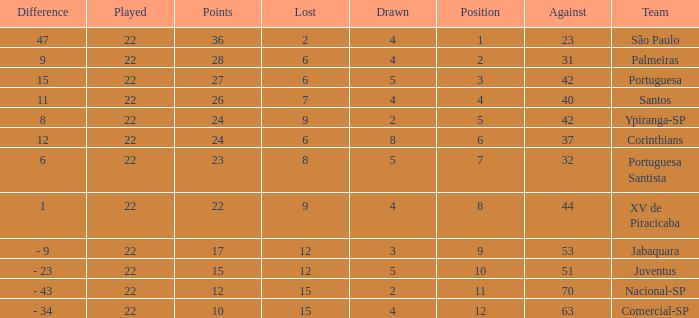Which Against has a Drawn smaller than 5, and a Lost smaller than 6, and a Points larger than 36? 0.0. 